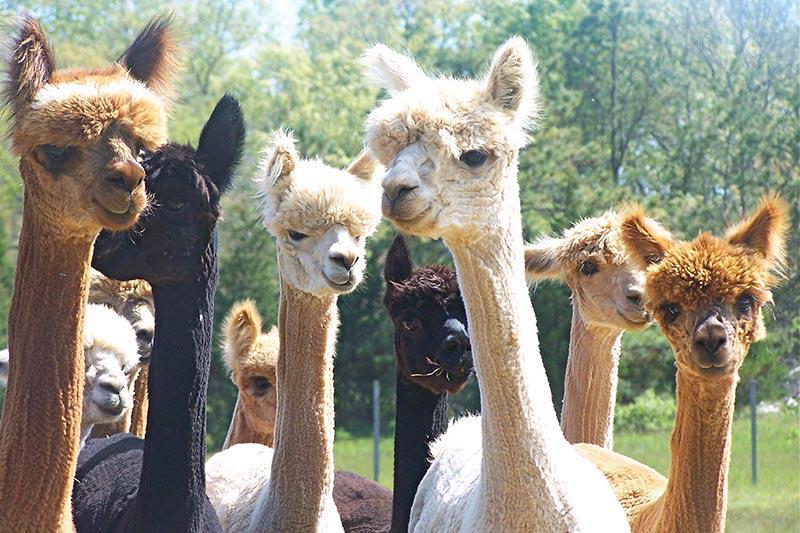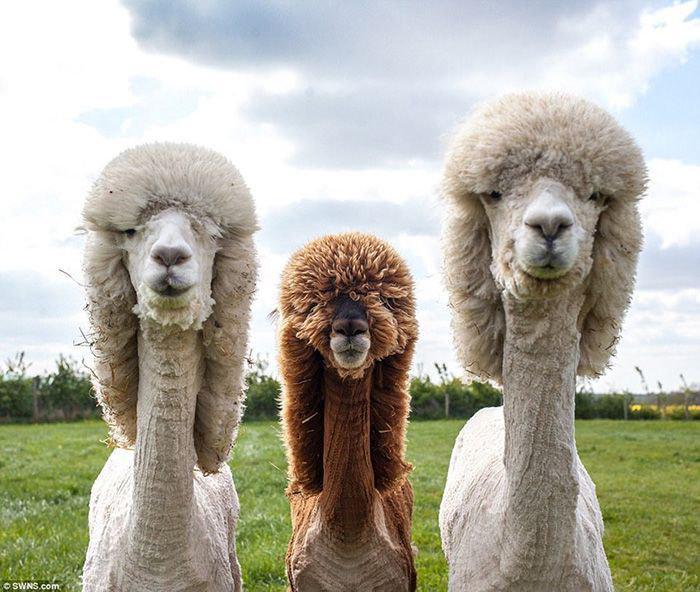The first image is the image on the left, the second image is the image on the right. Examine the images to the left and right. Is the description "At least some of the llamas have shaved necks." accurate? Answer yes or no. Yes. The first image is the image on the left, the second image is the image on the right. Given the left and right images, does the statement "At least one photo shows an animal that has had the hair on its neck shaved, and every photo has at least three animals." hold true? Answer yes or no. Yes. 